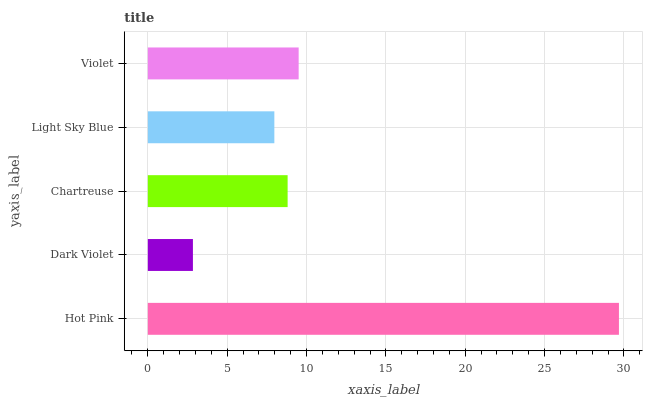Is Dark Violet the minimum?
Answer yes or no. Yes. Is Hot Pink the maximum?
Answer yes or no. Yes. Is Chartreuse the minimum?
Answer yes or no. No. Is Chartreuse the maximum?
Answer yes or no. No. Is Chartreuse greater than Dark Violet?
Answer yes or no. Yes. Is Dark Violet less than Chartreuse?
Answer yes or no. Yes. Is Dark Violet greater than Chartreuse?
Answer yes or no. No. Is Chartreuse less than Dark Violet?
Answer yes or no. No. Is Chartreuse the high median?
Answer yes or no. Yes. Is Chartreuse the low median?
Answer yes or no. Yes. Is Violet the high median?
Answer yes or no. No. Is Violet the low median?
Answer yes or no. No. 